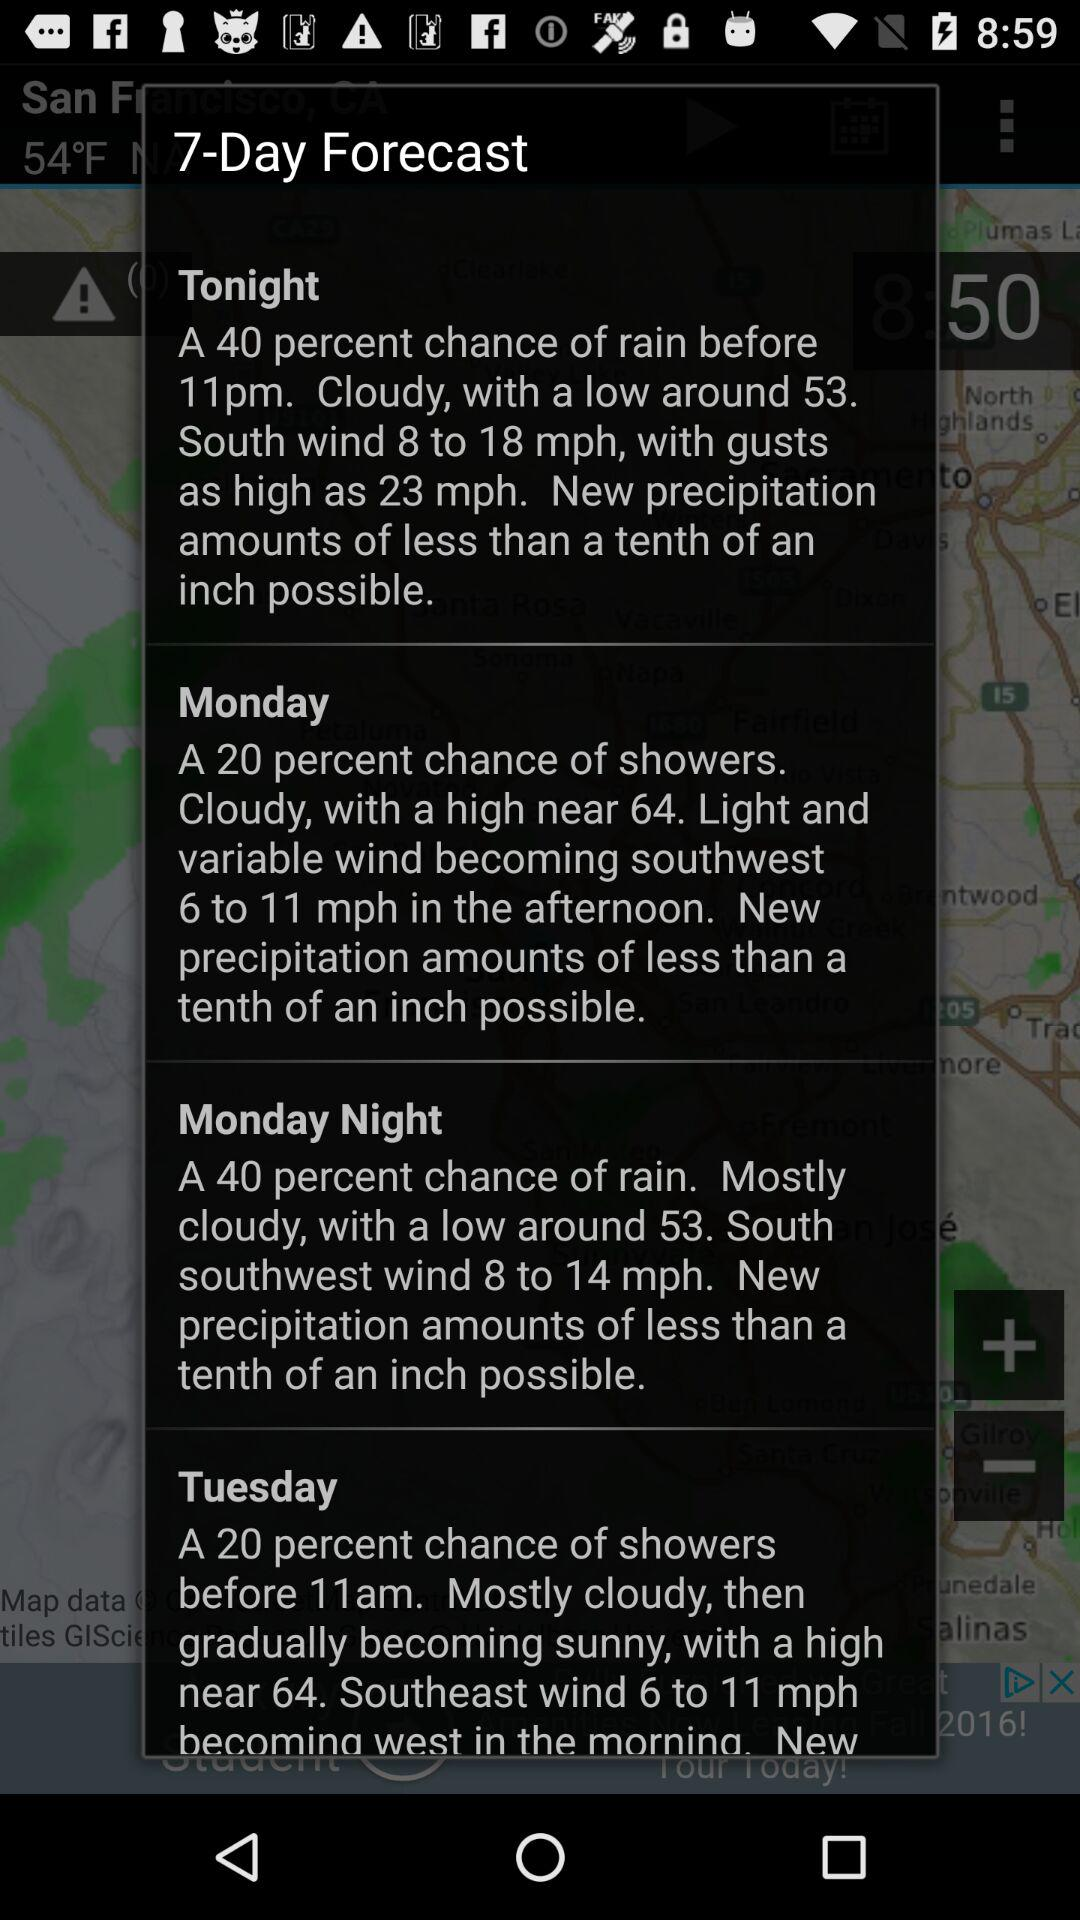What is the weather forecast for Monday? The weather forecast for Monday is "A 20 percent chance of showers. Cloudy, with a high near 64. Light and variable wind becoming southwest 6 to 11 mph in the afternoon. New precipitation amounts of less than a tenth of an inch possible.". 